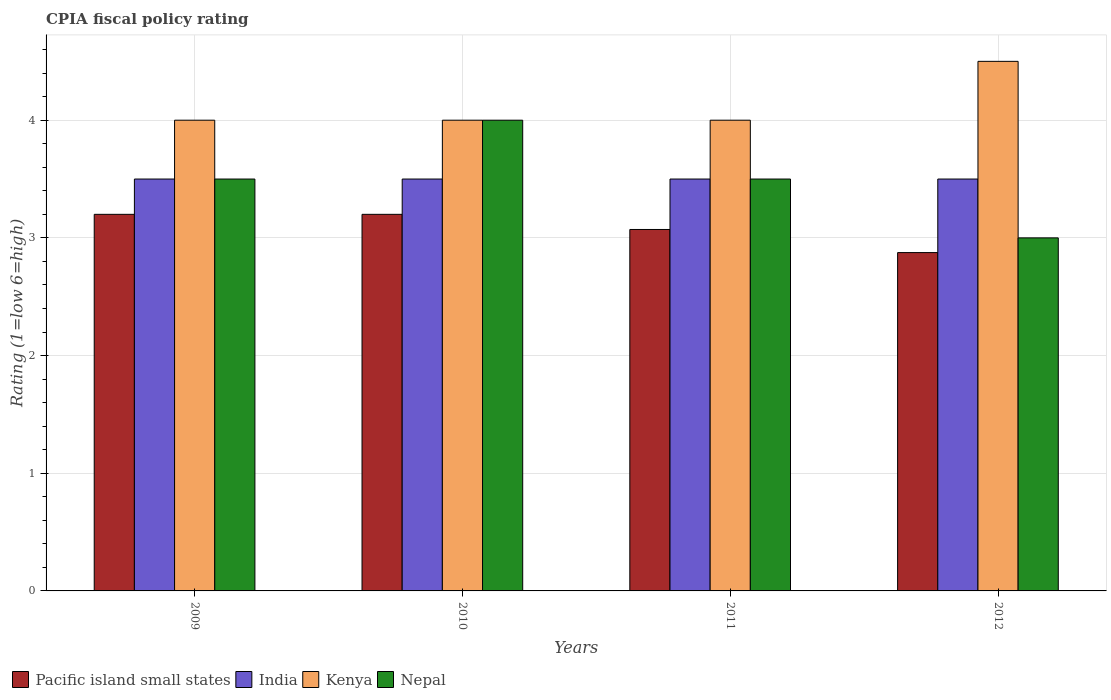Are the number of bars per tick equal to the number of legend labels?
Ensure brevity in your answer.  Yes. How many bars are there on the 4th tick from the left?
Make the answer very short. 4. How many bars are there on the 4th tick from the right?
Offer a terse response. 4. What is the label of the 1st group of bars from the left?
Make the answer very short. 2009. What is the CPIA rating in Kenya in 2010?
Keep it short and to the point. 4. Across all years, what is the maximum CPIA rating in Nepal?
Ensure brevity in your answer.  4. Across all years, what is the minimum CPIA rating in Pacific island small states?
Make the answer very short. 2.88. In which year was the CPIA rating in Kenya minimum?
Your response must be concise. 2009. What is the total CPIA rating in Nepal in the graph?
Give a very brief answer. 14. What is the difference between the CPIA rating in India in 2011 and that in 2012?
Provide a short and direct response. 0. What is the difference between the CPIA rating in Kenya in 2010 and the CPIA rating in Nepal in 2009?
Make the answer very short. 0.5. What is the average CPIA rating in Pacific island small states per year?
Offer a terse response. 3.09. In the year 2011, what is the difference between the CPIA rating in Kenya and CPIA rating in Pacific island small states?
Keep it short and to the point. 0.93. In how many years, is the CPIA rating in India greater than 3.2?
Your response must be concise. 4. What is the ratio of the CPIA rating in Nepal in 2010 to that in 2011?
Offer a very short reply. 1.14. What is the difference between the highest and the second highest CPIA rating in Nepal?
Ensure brevity in your answer.  0.5. What is the difference between the highest and the lowest CPIA rating in Pacific island small states?
Offer a very short reply. 0.33. What does the 4th bar from the left in 2009 represents?
Your answer should be very brief. Nepal. What does the 1st bar from the right in 2011 represents?
Give a very brief answer. Nepal. How many years are there in the graph?
Your response must be concise. 4. Where does the legend appear in the graph?
Your answer should be very brief. Bottom left. How many legend labels are there?
Provide a succinct answer. 4. What is the title of the graph?
Give a very brief answer. CPIA fiscal policy rating. Does "Lebanon" appear as one of the legend labels in the graph?
Give a very brief answer. No. What is the label or title of the Y-axis?
Ensure brevity in your answer.  Rating (1=low 6=high). What is the Rating (1=low 6=high) of Pacific island small states in 2009?
Provide a succinct answer. 3.2. What is the Rating (1=low 6=high) in India in 2009?
Give a very brief answer. 3.5. What is the Rating (1=low 6=high) in Kenya in 2009?
Give a very brief answer. 4. What is the Rating (1=low 6=high) in India in 2010?
Make the answer very short. 3.5. What is the Rating (1=low 6=high) in Kenya in 2010?
Make the answer very short. 4. What is the Rating (1=low 6=high) in Nepal in 2010?
Provide a succinct answer. 4. What is the Rating (1=low 6=high) of Pacific island small states in 2011?
Provide a short and direct response. 3.07. What is the Rating (1=low 6=high) in India in 2011?
Your answer should be very brief. 3.5. What is the Rating (1=low 6=high) in Kenya in 2011?
Your answer should be very brief. 4. What is the Rating (1=low 6=high) in Pacific island small states in 2012?
Offer a very short reply. 2.88. What is the Rating (1=low 6=high) of India in 2012?
Your answer should be compact. 3.5. Across all years, what is the maximum Rating (1=low 6=high) in Pacific island small states?
Offer a very short reply. 3.2. Across all years, what is the maximum Rating (1=low 6=high) in India?
Offer a terse response. 3.5. Across all years, what is the minimum Rating (1=low 6=high) of Pacific island small states?
Make the answer very short. 2.88. Across all years, what is the minimum Rating (1=low 6=high) of Nepal?
Provide a succinct answer. 3. What is the total Rating (1=low 6=high) of Pacific island small states in the graph?
Keep it short and to the point. 12.35. What is the total Rating (1=low 6=high) of India in the graph?
Offer a terse response. 14. What is the difference between the Rating (1=low 6=high) in Pacific island small states in 2009 and that in 2010?
Your answer should be compact. 0. What is the difference between the Rating (1=low 6=high) of India in 2009 and that in 2010?
Provide a succinct answer. 0. What is the difference between the Rating (1=low 6=high) in Kenya in 2009 and that in 2010?
Your response must be concise. 0. What is the difference between the Rating (1=low 6=high) of Pacific island small states in 2009 and that in 2011?
Ensure brevity in your answer.  0.13. What is the difference between the Rating (1=low 6=high) in Pacific island small states in 2009 and that in 2012?
Provide a short and direct response. 0.33. What is the difference between the Rating (1=low 6=high) of India in 2009 and that in 2012?
Offer a very short reply. 0. What is the difference between the Rating (1=low 6=high) of Pacific island small states in 2010 and that in 2011?
Offer a terse response. 0.13. What is the difference between the Rating (1=low 6=high) of Kenya in 2010 and that in 2011?
Your response must be concise. 0. What is the difference between the Rating (1=low 6=high) of Pacific island small states in 2010 and that in 2012?
Keep it short and to the point. 0.33. What is the difference between the Rating (1=low 6=high) in India in 2010 and that in 2012?
Provide a succinct answer. 0. What is the difference between the Rating (1=low 6=high) in Kenya in 2010 and that in 2012?
Ensure brevity in your answer.  -0.5. What is the difference between the Rating (1=low 6=high) in Pacific island small states in 2011 and that in 2012?
Offer a very short reply. 0.2. What is the difference between the Rating (1=low 6=high) of Kenya in 2011 and that in 2012?
Keep it short and to the point. -0.5. What is the difference between the Rating (1=low 6=high) in Pacific island small states in 2009 and the Rating (1=low 6=high) in India in 2010?
Make the answer very short. -0.3. What is the difference between the Rating (1=low 6=high) of Pacific island small states in 2009 and the Rating (1=low 6=high) of Kenya in 2010?
Make the answer very short. -0.8. What is the difference between the Rating (1=low 6=high) in India in 2009 and the Rating (1=low 6=high) in Kenya in 2010?
Provide a succinct answer. -0.5. What is the difference between the Rating (1=low 6=high) in Kenya in 2009 and the Rating (1=low 6=high) in Nepal in 2010?
Your answer should be compact. 0. What is the difference between the Rating (1=low 6=high) of Pacific island small states in 2009 and the Rating (1=low 6=high) of India in 2011?
Make the answer very short. -0.3. What is the difference between the Rating (1=low 6=high) of Pacific island small states in 2009 and the Rating (1=low 6=high) of Kenya in 2011?
Your answer should be very brief. -0.8. What is the difference between the Rating (1=low 6=high) of Kenya in 2009 and the Rating (1=low 6=high) of Nepal in 2011?
Ensure brevity in your answer.  0.5. What is the difference between the Rating (1=low 6=high) in Pacific island small states in 2009 and the Rating (1=low 6=high) in Nepal in 2012?
Keep it short and to the point. 0.2. What is the difference between the Rating (1=low 6=high) in Pacific island small states in 2010 and the Rating (1=low 6=high) in India in 2011?
Provide a short and direct response. -0.3. What is the difference between the Rating (1=low 6=high) in Pacific island small states in 2010 and the Rating (1=low 6=high) in Kenya in 2011?
Your response must be concise. -0.8. What is the difference between the Rating (1=low 6=high) in Pacific island small states in 2010 and the Rating (1=low 6=high) in Nepal in 2011?
Your response must be concise. -0.3. What is the difference between the Rating (1=low 6=high) of Kenya in 2010 and the Rating (1=low 6=high) of Nepal in 2011?
Offer a very short reply. 0.5. What is the difference between the Rating (1=low 6=high) of India in 2010 and the Rating (1=low 6=high) of Kenya in 2012?
Offer a terse response. -1. What is the difference between the Rating (1=low 6=high) of India in 2010 and the Rating (1=low 6=high) of Nepal in 2012?
Give a very brief answer. 0.5. What is the difference between the Rating (1=low 6=high) in Pacific island small states in 2011 and the Rating (1=low 6=high) in India in 2012?
Your answer should be very brief. -0.43. What is the difference between the Rating (1=low 6=high) of Pacific island small states in 2011 and the Rating (1=low 6=high) of Kenya in 2012?
Make the answer very short. -1.43. What is the difference between the Rating (1=low 6=high) of Pacific island small states in 2011 and the Rating (1=low 6=high) of Nepal in 2012?
Your answer should be very brief. 0.07. What is the difference between the Rating (1=low 6=high) in India in 2011 and the Rating (1=low 6=high) in Kenya in 2012?
Give a very brief answer. -1. What is the difference between the Rating (1=low 6=high) in India in 2011 and the Rating (1=low 6=high) in Nepal in 2012?
Your answer should be compact. 0.5. What is the difference between the Rating (1=low 6=high) of Kenya in 2011 and the Rating (1=low 6=high) of Nepal in 2012?
Give a very brief answer. 1. What is the average Rating (1=low 6=high) of Pacific island small states per year?
Your response must be concise. 3.09. What is the average Rating (1=low 6=high) in India per year?
Ensure brevity in your answer.  3.5. What is the average Rating (1=low 6=high) of Kenya per year?
Offer a terse response. 4.12. In the year 2009, what is the difference between the Rating (1=low 6=high) in Pacific island small states and Rating (1=low 6=high) in India?
Offer a very short reply. -0.3. In the year 2009, what is the difference between the Rating (1=low 6=high) in Pacific island small states and Rating (1=low 6=high) in Kenya?
Ensure brevity in your answer.  -0.8. In the year 2009, what is the difference between the Rating (1=low 6=high) of India and Rating (1=low 6=high) of Kenya?
Your response must be concise. -0.5. In the year 2009, what is the difference between the Rating (1=low 6=high) in India and Rating (1=low 6=high) in Nepal?
Provide a short and direct response. 0. In the year 2009, what is the difference between the Rating (1=low 6=high) in Kenya and Rating (1=low 6=high) in Nepal?
Provide a short and direct response. 0.5. In the year 2010, what is the difference between the Rating (1=low 6=high) of Pacific island small states and Rating (1=low 6=high) of Kenya?
Ensure brevity in your answer.  -0.8. In the year 2011, what is the difference between the Rating (1=low 6=high) of Pacific island small states and Rating (1=low 6=high) of India?
Offer a terse response. -0.43. In the year 2011, what is the difference between the Rating (1=low 6=high) of Pacific island small states and Rating (1=low 6=high) of Kenya?
Provide a short and direct response. -0.93. In the year 2011, what is the difference between the Rating (1=low 6=high) of Pacific island small states and Rating (1=low 6=high) of Nepal?
Provide a succinct answer. -0.43. In the year 2011, what is the difference between the Rating (1=low 6=high) of India and Rating (1=low 6=high) of Kenya?
Your answer should be compact. -0.5. In the year 2011, what is the difference between the Rating (1=low 6=high) in Kenya and Rating (1=low 6=high) in Nepal?
Provide a succinct answer. 0.5. In the year 2012, what is the difference between the Rating (1=low 6=high) of Pacific island small states and Rating (1=low 6=high) of India?
Your answer should be very brief. -0.62. In the year 2012, what is the difference between the Rating (1=low 6=high) in Pacific island small states and Rating (1=low 6=high) in Kenya?
Provide a short and direct response. -1.62. In the year 2012, what is the difference between the Rating (1=low 6=high) of Pacific island small states and Rating (1=low 6=high) of Nepal?
Offer a terse response. -0.12. What is the ratio of the Rating (1=low 6=high) in Pacific island small states in 2009 to that in 2011?
Your answer should be compact. 1.04. What is the ratio of the Rating (1=low 6=high) of Pacific island small states in 2009 to that in 2012?
Keep it short and to the point. 1.11. What is the ratio of the Rating (1=low 6=high) in Pacific island small states in 2010 to that in 2011?
Offer a very short reply. 1.04. What is the ratio of the Rating (1=low 6=high) of Kenya in 2010 to that in 2011?
Offer a very short reply. 1. What is the ratio of the Rating (1=low 6=high) in Pacific island small states in 2010 to that in 2012?
Provide a short and direct response. 1.11. What is the ratio of the Rating (1=low 6=high) in Kenya in 2010 to that in 2012?
Provide a short and direct response. 0.89. What is the ratio of the Rating (1=low 6=high) in Pacific island small states in 2011 to that in 2012?
Your response must be concise. 1.07. What is the ratio of the Rating (1=low 6=high) of India in 2011 to that in 2012?
Make the answer very short. 1. What is the difference between the highest and the second highest Rating (1=low 6=high) of India?
Your response must be concise. 0. What is the difference between the highest and the second highest Rating (1=low 6=high) of Kenya?
Give a very brief answer. 0.5. What is the difference between the highest and the lowest Rating (1=low 6=high) in Pacific island small states?
Provide a short and direct response. 0.33. What is the difference between the highest and the lowest Rating (1=low 6=high) in India?
Make the answer very short. 0. What is the difference between the highest and the lowest Rating (1=low 6=high) in Kenya?
Provide a short and direct response. 0.5. 